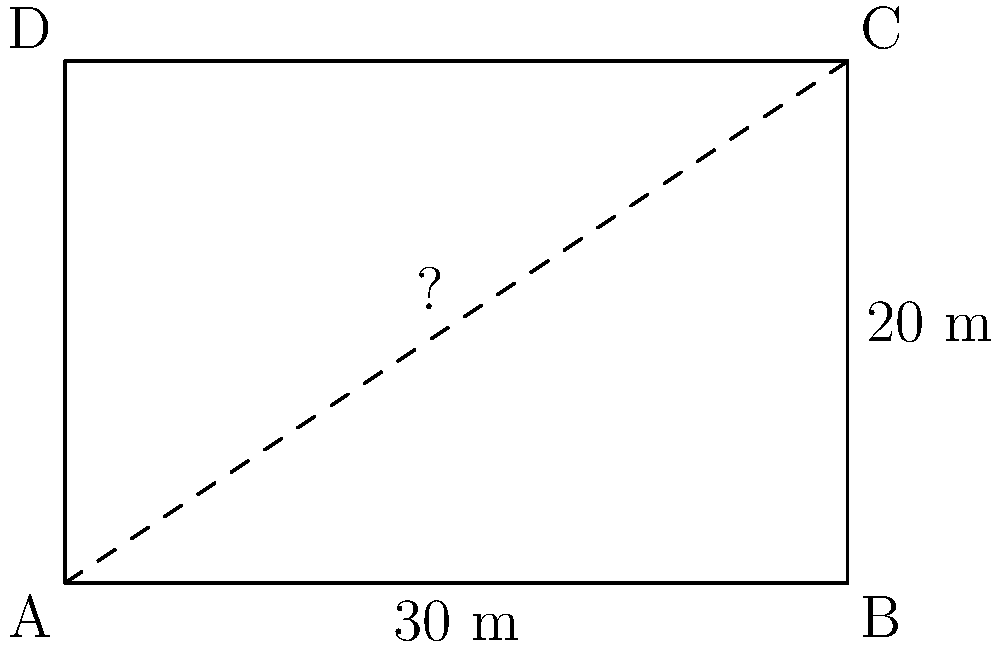As an IT manager planning an in-house data center, you need to calculate the length of network cables that will run diagonally across the room. Given a rectangular data center floor plan with dimensions 30 meters by 20 meters, what is the length of the diagonal in meters? Round your answer to two decimal places. To find the diagonal length of the rectangular data center floor, we can use the Pythagorean theorem:

1) Let's denote the diagonal as $d$, the length as $l = 30\text{ m}$, and the width as $w = 20\text{ m}$.

2) According to the Pythagorean theorem:
   $d^2 = l^2 + w^2$

3) Substituting the values:
   $d^2 = 30^2 + 20^2$

4) Simplify:
   $d^2 = 900 + 400 = 1300$

5) Take the square root of both sides:
   $d = \sqrt{1300}$

6) Calculate and round to two decimal places:
   $d \approx 36.06\text{ m}$

Therefore, the diagonal length of the data center floor is approximately 36.06 meters.
Answer: 36.06 m 